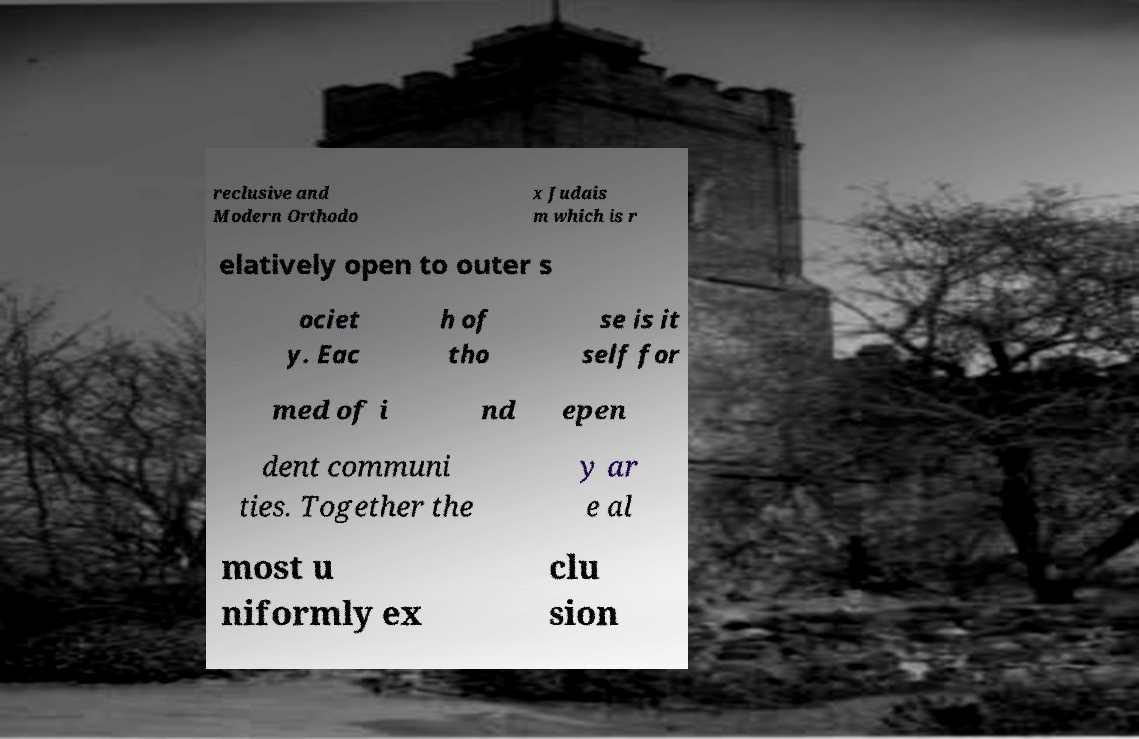Could you extract and type out the text from this image? reclusive and Modern Orthodo x Judais m which is r elatively open to outer s ociet y. Eac h of tho se is it self for med of i nd epen dent communi ties. Together the y ar e al most u niformly ex clu sion 